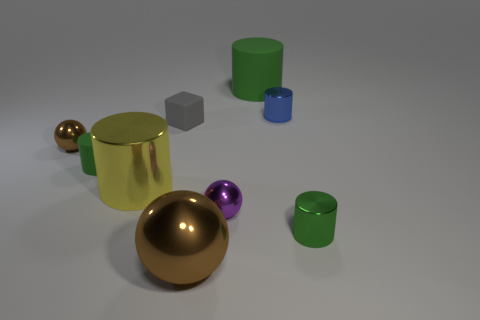Is there any other thing that has the same color as the large matte thing?
Offer a very short reply. Yes. Does the tiny brown object have the same material as the yellow cylinder?
Provide a short and direct response. Yes. There is a blue cylinder that is behind the green matte cylinder that is in front of the big green thing; how many large metallic things are in front of it?
Make the answer very short. 2. How many blue cubes are there?
Offer a terse response. 0. Is the number of large shiny objects right of the purple metallic sphere less than the number of green cylinders right of the matte block?
Make the answer very short. Yes. Is the number of purple spheres that are on the right side of the blue metal thing less than the number of tiny green metal cylinders?
Provide a succinct answer. Yes. There is a small green cylinder that is left of the block behind the tiny green cylinder that is in front of the yellow thing; what is it made of?
Your response must be concise. Rubber. What number of objects are big yellow shiny things behind the green shiny object or green cylinders behind the green shiny cylinder?
Your response must be concise. 3. There is a big green object that is the same shape as the tiny green matte object; what is it made of?
Offer a very short reply. Rubber. How many shiny things are either tiny green objects or large blue spheres?
Provide a short and direct response. 1. 